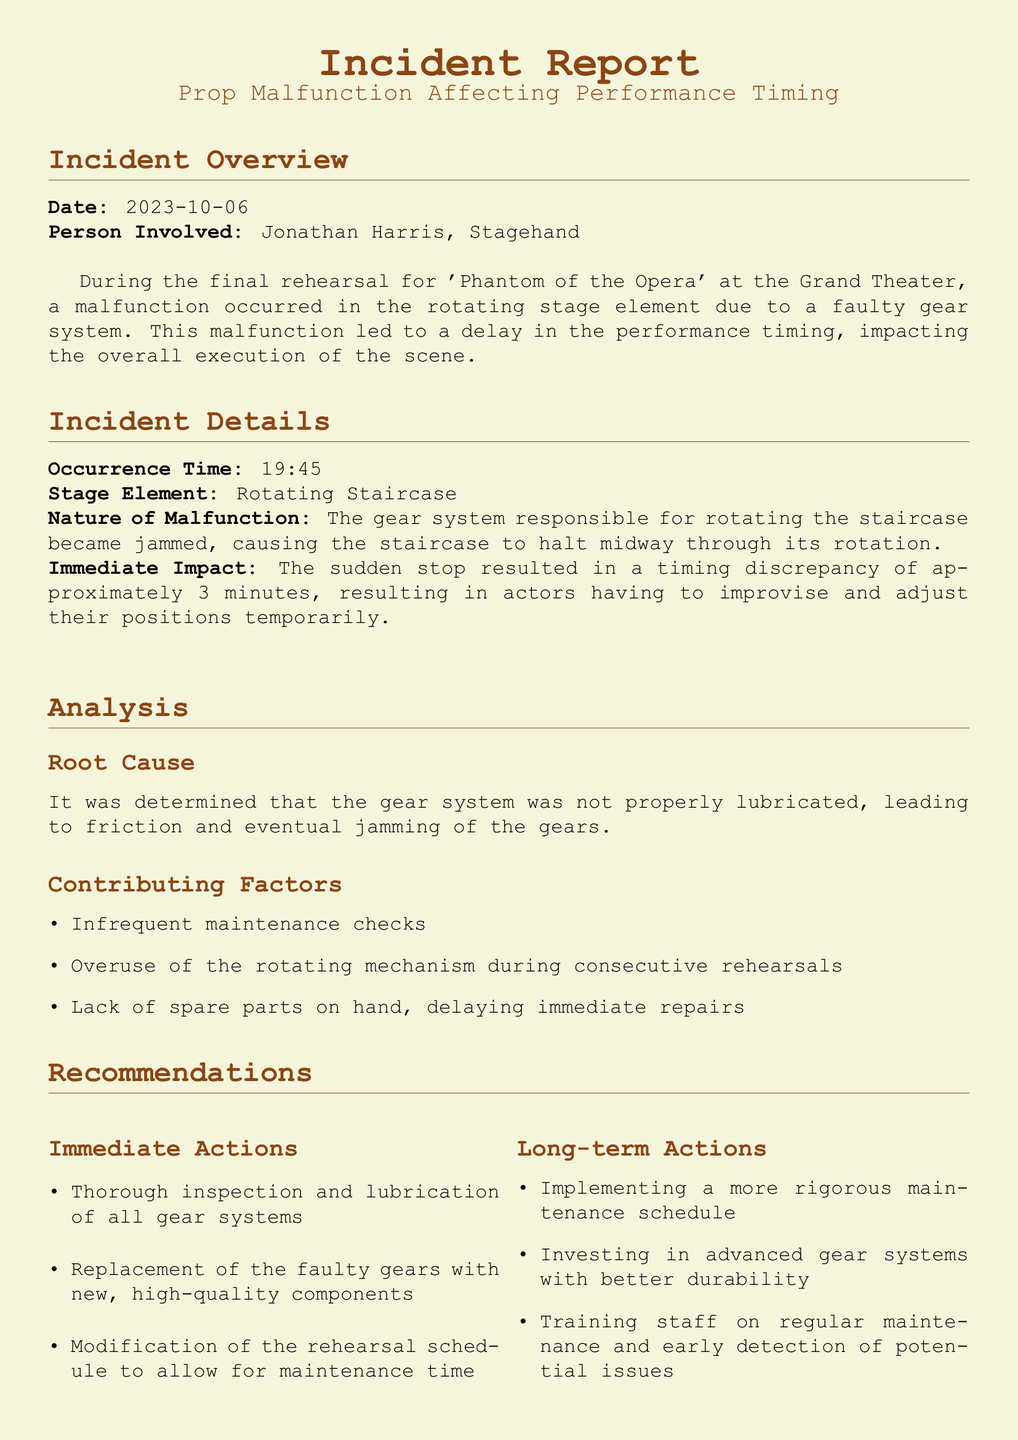What was the date of the incident? The date of the incident is specified in the report.
Answer: 2023-10-06 Who was involved in the incident? The report mentions the person involved in the incident.
Answer: Jonathan Harris What was the stage element affected? The document specifies the stage element associated with the incident.
Answer: Rotating Staircase What caused the malfunction? The incident report discusses the root cause of the malfunction in the gear system.
Answer: Not properly lubricated How long was the timing discrepancy? The report mentions the impact on performance timing due to the malfunction.
Answer: Approximately 3 minutes What immediate actions were recommended? The document lists recommended immediate actions following the incident.
Answer: Thorough inspection and lubrication of all gear systems What is one contributing factor to the malfunction? The report outlines several contributing factors to the malfunction; one can be picked easily.
Answer: Infrequent maintenance checks Who reviewed the incident report? The report lists the person who reviewed it.
Answer: Rachel Cooper, Stage Manager What long-term action is suggested for future prevention? The document specifies a long-term action suggested to prevent future issues.
Answer: Implementing a more rigorous maintenance schedule 